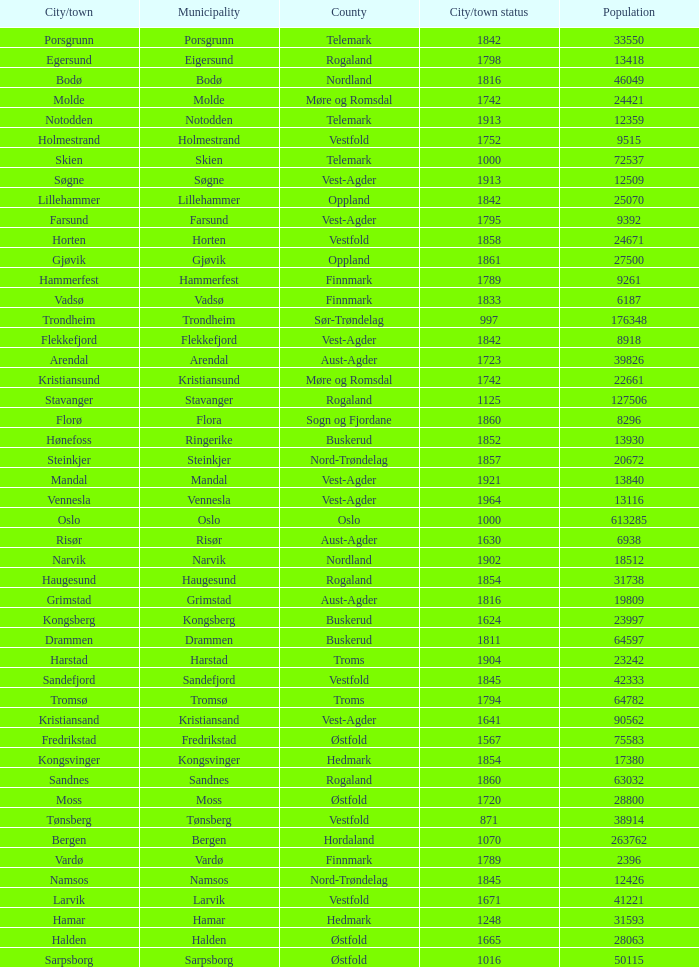What are the cities/towns located in the municipality of Moss? Moss. 